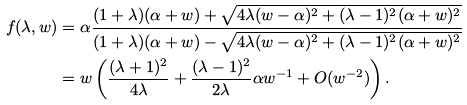<formula> <loc_0><loc_0><loc_500><loc_500>f ( \lambda , w ) & = \alpha \frac { ( 1 + \lambda ) ( \alpha + w ) + \sqrt { 4 \lambda ( w - \alpha ) ^ { 2 } + ( \lambda - 1 ) ^ { 2 } ( \alpha + w ) ^ { 2 } } } { ( 1 + \lambda ) ( \alpha + w ) - \sqrt { 4 \lambda ( w - \alpha ) ^ { 2 } + ( \lambda - 1 ) ^ { 2 } ( \alpha + w ) ^ { 2 } } } \\ & = w \left ( \frac { ( \lambda + 1 ) ^ { 2 } } { 4 \lambda } + \frac { ( \lambda - 1 ) ^ { 2 } } { 2 \lambda } \alpha w ^ { - 1 } + O ( w ^ { - 2 } ) \right ) .</formula> 